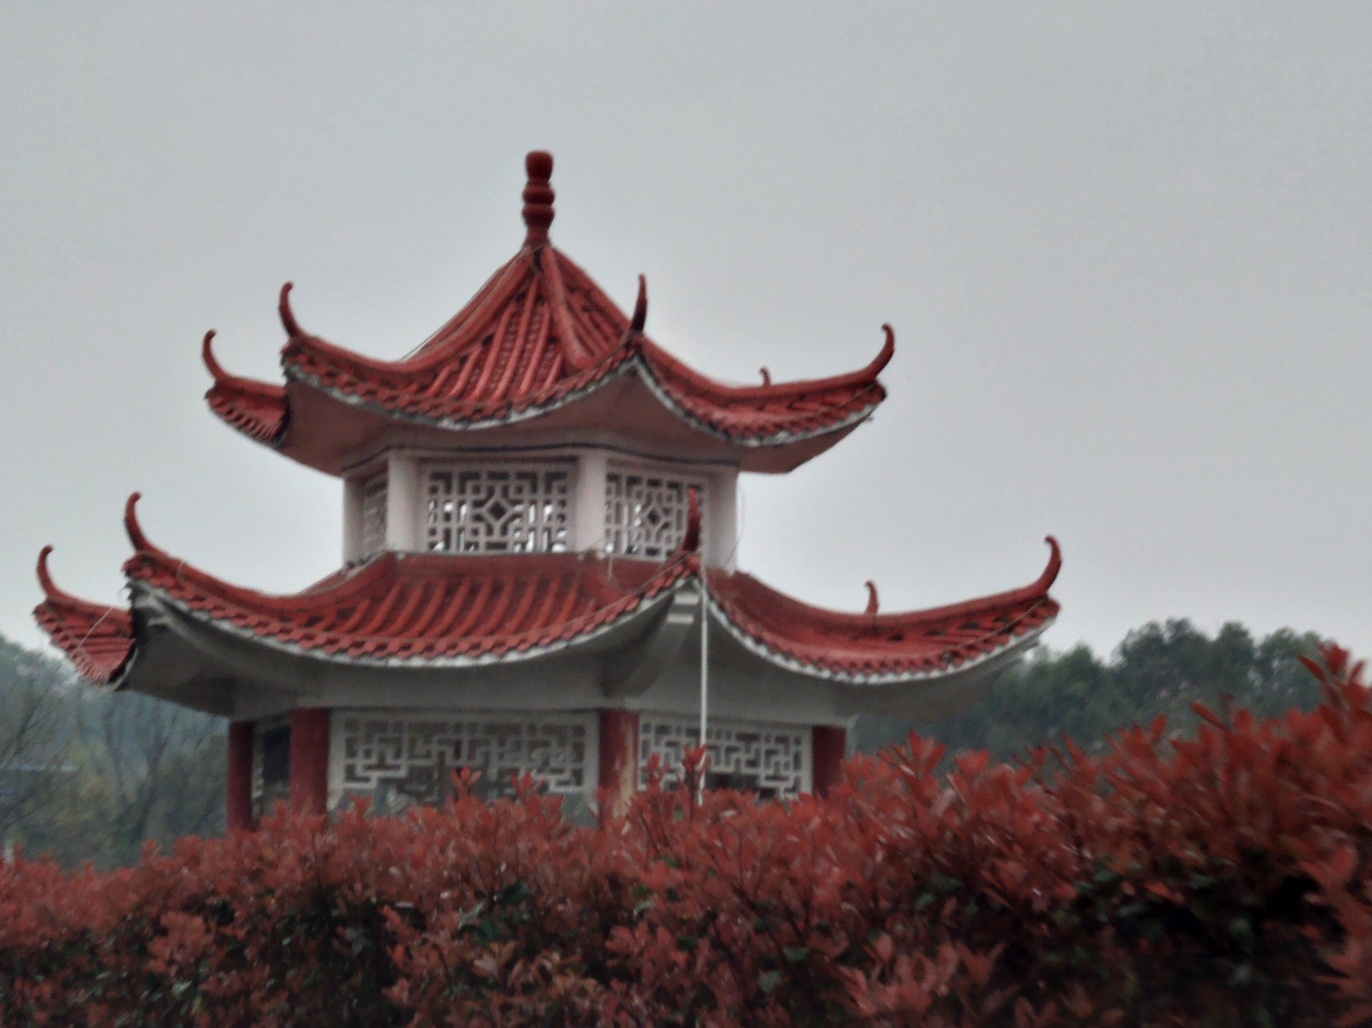What is the composition of this image? A. Strongly tilted B. Slightly tilted C. Completely horizontal Answer with the option's letter from the given choices directly. Option B is correct; the image is slightly tilted. You can tell because the structures in the image don't align perfectly with the edges of the photo frame, indicating a minor deviation from a perfectly horizontal perspective. 